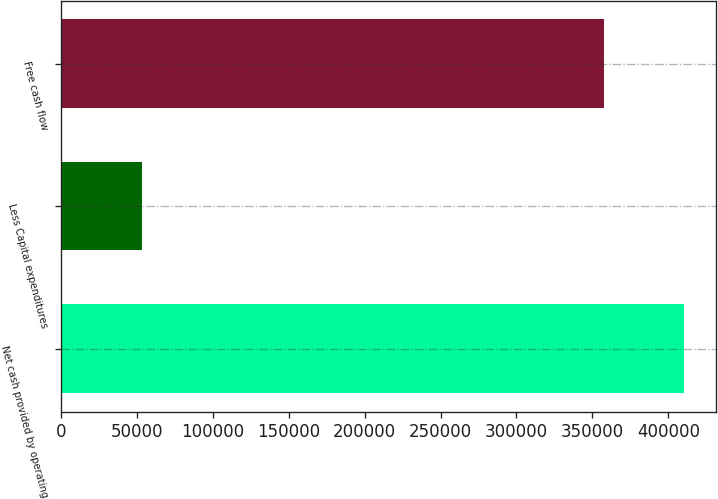Convert chart to OTSL. <chart><loc_0><loc_0><loc_500><loc_500><bar_chart><fcel>Net cash provided by operating<fcel>Less Capital expenditures<fcel>Free cash flow<nl><fcel>410590<fcel>53135<fcel>357455<nl></chart> 